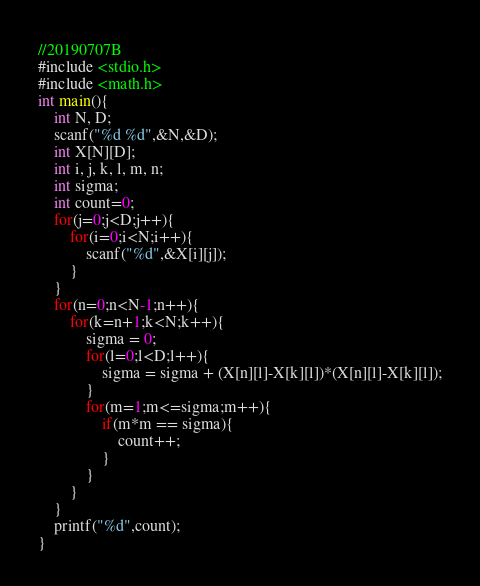<code> <loc_0><loc_0><loc_500><loc_500><_C_>//20190707B
#include <stdio.h>
#include <math.h>
int main(){
	int N, D;
	scanf("%d %d",&N,&D);
	int X[N][D];
	int i, j, k, l, m, n;
	int sigma;
	int count=0;
	for(j=0;j<D;j++){
		for(i=0;i<N;i++){
			scanf("%d",&X[i][j]);
		}
	}
	for(n=0;n<N-1;n++){
		for(k=n+1;k<N;k++){
			sigma = 0;
			for(l=0;l<D;l++){
				sigma = sigma + (X[n][l]-X[k][l])*(X[n][l]-X[k][l]);
			}
			for(m=1;m<=sigma;m++){
				if(m*m == sigma){
					count++;
				}
			}
		}
	}
	printf("%d",count);
}</code> 